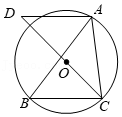As shown in the figure, triangle ABC is inscribed in circle O, angle BAC = 50°. AD is drawn parallel to BC passing through point A, and it intersects the extension of CO at point D. The degree of angle D is (). Choices: A: 50° B: 45° C: 40° D: 25° To find the measure of angle D in the given configuration where the triangle ABC is inscribed in circle O, we start by noting that angle BAC = 50°. Drawing OB creates two arcs split by point A. The angle at the center, BOC, thus measures 100° as it is twice the inscribed angle BAC due to the Circle's Inscribed Angle Theorem. Dividing the remaining 180° arc (the sum of angles at a point in a circle) by two gives each angle as 40°. Since AD is parallel to BC, the corresponding angle D would also measure the same as angle OCB because of the Alternate Interior Angles Theorem, resulting in the angle measurement of D to be 40°. Therefore, the correct choice is C: 40°. 